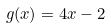Convert formula to latex. <formula><loc_0><loc_0><loc_500><loc_500>g ( x ) = 4 x - 2</formula> 